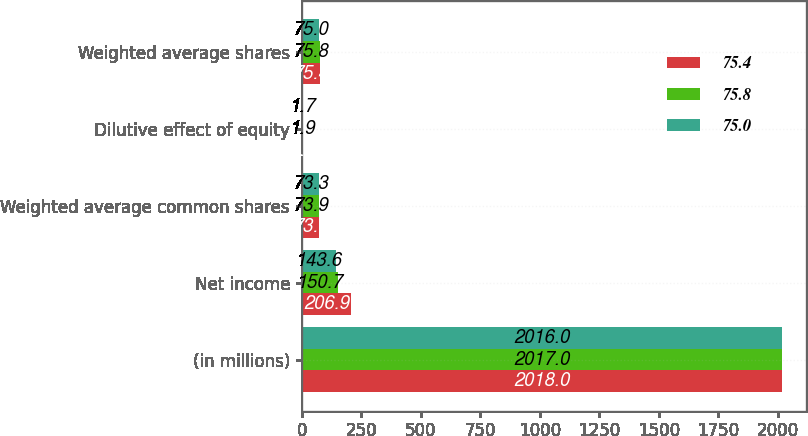Convert chart to OTSL. <chart><loc_0><loc_0><loc_500><loc_500><stacked_bar_chart><ecel><fcel>(in millions)<fcel>Net income<fcel>Weighted average common shares<fcel>Dilutive effect of equity<fcel>Weighted average shares<nl><fcel>75.4<fcel>2018<fcel>206.9<fcel>73.9<fcel>1.5<fcel>75.4<nl><fcel>75.8<fcel>2017<fcel>150.7<fcel>73.9<fcel>1.9<fcel>75.8<nl><fcel>75<fcel>2016<fcel>143.6<fcel>73.3<fcel>1.7<fcel>75<nl></chart> 